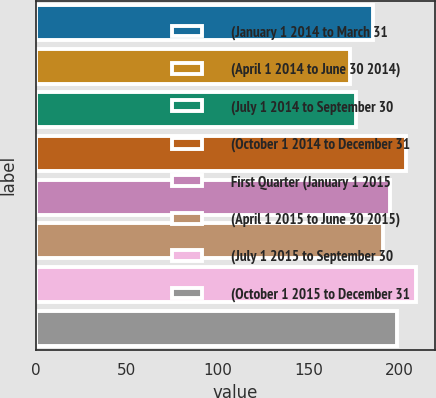Convert chart to OTSL. <chart><loc_0><loc_0><loc_500><loc_500><bar_chart><fcel>(January 1 2014 to March 31<fcel>(April 1 2014 to June 30 2014)<fcel>(July 1 2014 to September 30<fcel>(October 1 2014 to December 31<fcel>First Quarter (January 1 2015<fcel>(April 1 2015 to June 30 2015)<fcel>(July 1 2015 to September 30<fcel>(October 1 2015 to December 31<nl><fcel>185.43<fcel>172.5<fcel>176.14<fcel>203.3<fcel>194.64<fcel>191<fcel>208.88<fcel>198.28<nl></chart> 